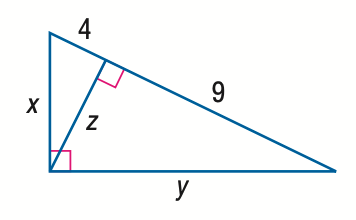Could you explain why a right triangle is relevant in real-world applications? Right triangles are extremely relevant in real-world applications because they form the basis for trigonometry, which is used in many fields such as architecture, engineering, physics, and navigational systems. For instance, engineers may use the principles of right triangles to determine the proper angles and lengths of components for stability and safety, while GPS systems use trigonometry to calculate distances and locations based on satellite data. 